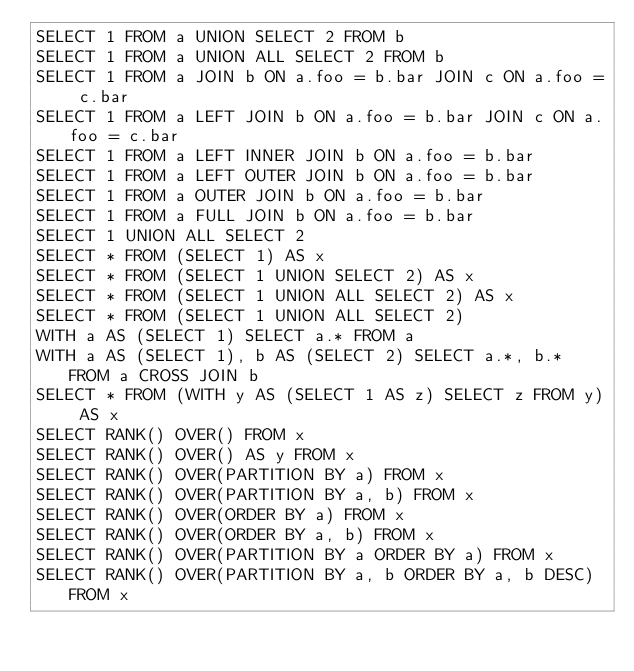<code> <loc_0><loc_0><loc_500><loc_500><_SQL_>SELECT 1 FROM a UNION SELECT 2 FROM b
SELECT 1 FROM a UNION ALL SELECT 2 FROM b
SELECT 1 FROM a JOIN b ON a.foo = b.bar JOIN c ON a.foo = c.bar
SELECT 1 FROM a LEFT JOIN b ON a.foo = b.bar JOIN c ON a.foo = c.bar
SELECT 1 FROM a LEFT INNER JOIN b ON a.foo = b.bar
SELECT 1 FROM a LEFT OUTER JOIN b ON a.foo = b.bar
SELECT 1 FROM a OUTER JOIN b ON a.foo = b.bar
SELECT 1 FROM a FULL JOIN b ON a.foo = b.bar
SELECT 1 UNION ALL SELECT 2
SELECT * FROM (SELECT 1) AS x
SELECT * FROM (SELECT 1 UNION SELECT 2) AS x
SELECT * FROM (SELECT 1 UNION ALL SELECT 2) AS x
SELECT * FROM (SELECT 1 UNION ALL SELECT 2)
WITH a AS (SELECT 1) SELECT a.* FROM a
WITH a AS (SELECT 1), b AS (SELECT 2) SELECT a.*, b.* FROM a CROSS JOIN b
SELECT * FROM (WITH y AS (SELECT 1 AS z) SELECT z FROM y) AS x
SELECT RANK() OVER() FROM x
SELECT RANK() OVER() AS y FROM x
SELECT RANK() OVER(PARTITION BY a) FROM x
SELECT RANK() OVER(PARTITION BY a, b) FROM x
SELECT RANK() OVER(ORDER BY a) FROM x
SELECT RANK() OVER(ORDER BY a, b) FROM x
SELECT RANK() OVER(PARTITION BY a ORDER BY a) FROM x
SELECT RANK() OVER(PARTITION BY a, b ORDER BY a, b DESC) FROM x</code> 